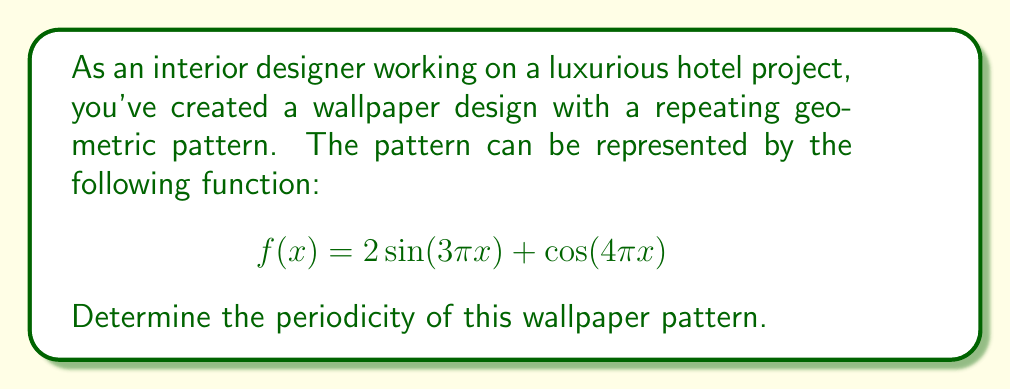Help me with this question. To find the periodicity of the wallpaper pattern, we need to determine the least common multiple (LCM) of the periods of the individual sinusoidal components.

1. For the first term, $2\sin(3\pi x)$:
   The general form of a sine function is $\sin(2\pi x / T)$, where $T$ is the period.
   So, $3\pi = 2\pi / T_1$
   $T_1 = 2/3$

2. For the second term, $\cos(4\pi x)$:
   The general form of a cosine function is $\cos(2\pi x / T)$, where $T$ is the period.
   So, $4\pi = 2\pi / T_2$
   $T_2 = 1/2$

3. Now, we need to find the LCM of $T_1$ and $T_2$:
   $LCM(2/3, 1/2) = LCM(4/6, 3/6) = 2$

Therefore, the overall pattern will repeat every 2 units.

To verify this result, we can check:
$$f(x+2) = 2\sin(3\pi(x+2)) + \cos(4\pi(x+2))$$
$$= 2\sin(3\pi x + 6\pi) + \cos(4\pi x + 8\pi)$$
$$= 2\sin(3\pi x) + \cos(4\pi x)$$
$$= f(x)$$

This confirms that the pattern indeed repeats every 2 units.
Answer: The periodicity of the wallpaper pattern is 2 units. 